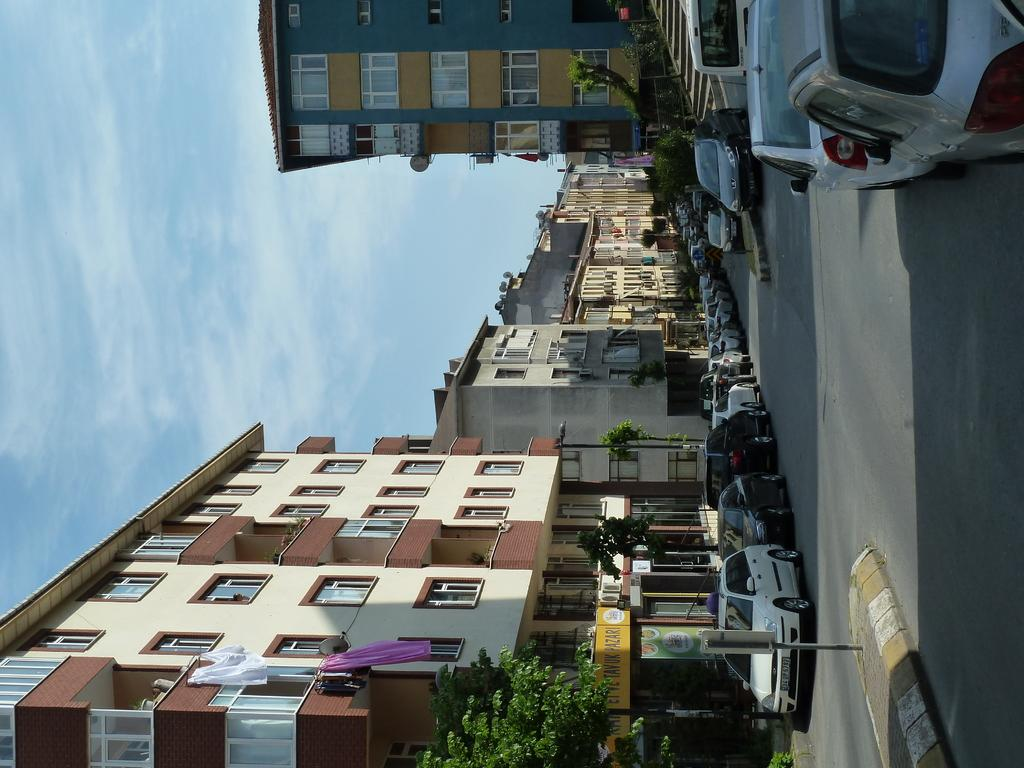What type of vehicles can be seen on the road in the image? There are cars on the road in the image. What object can be seen in the image that might be used for displaying information or advertisements? There is a board in the image. What type of structures are visible in the image? There are buildings in the image. What type of vegetation can be seen in the image? There are trees in the image. What type of vertical structures can be seen in the image? There are poles in the image. What can be seen in the sky at the top of the image? There are clouds in the sky at the top of the image. Can you see any crooks or wounds on the cars in the image? There are no crooks or wounds present on the cars in the image. Is there a cork floating in the sky in the image? There is no cork present in the image; only clouds can be seen in the sky. 